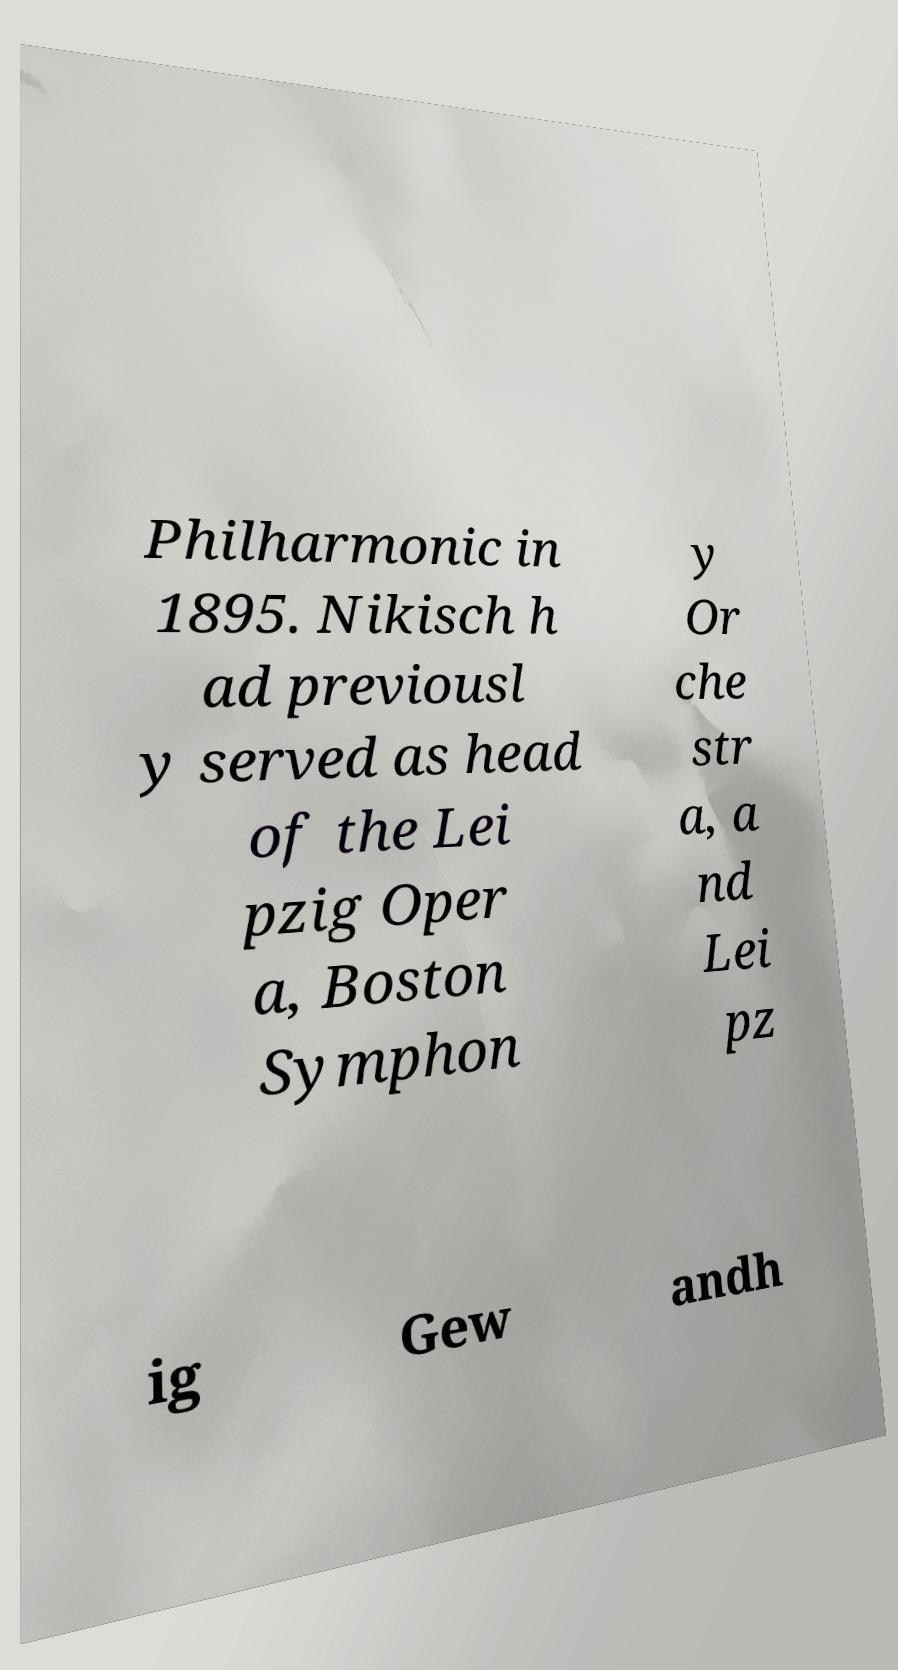Please read and relay the text visible in this image. What does it say? Philharmonic in 1895. Nikisch h ad previousl y served as head of the Lei pzig Oper a, Boston Symphon y Or che str a, a nd Lei pz ig Gew andh 